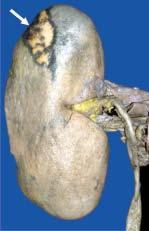s the wedge-shaped infarct slightly depressed on the surface?
Answer the question using a single word or phrase. Yes 